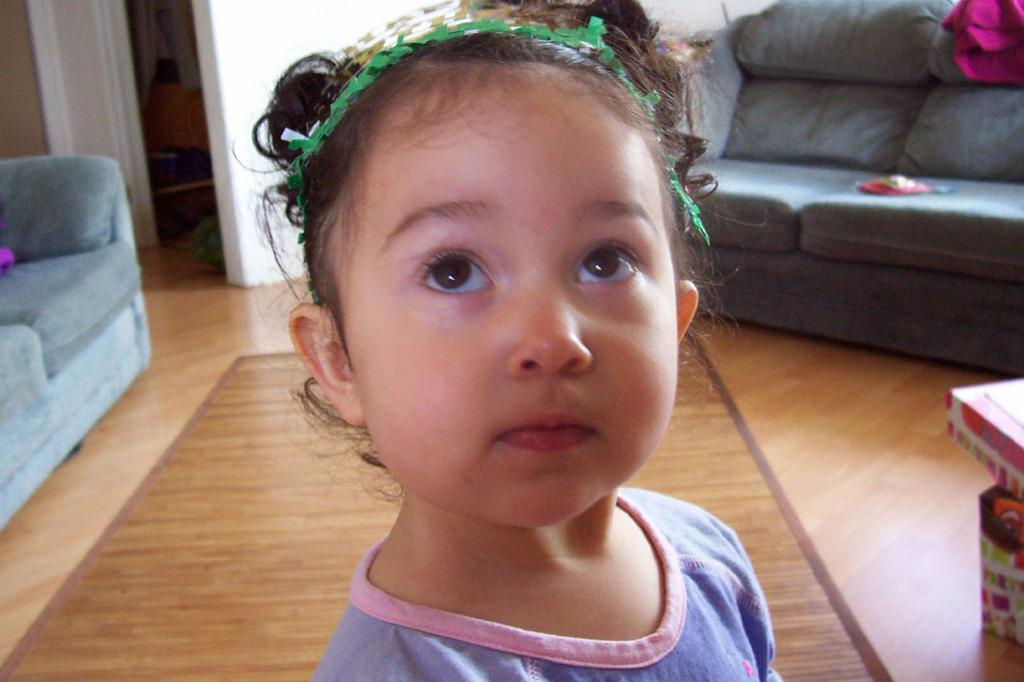Who is the main subject in the image? There is a girl in the image. What is the girl doing in the image? The girl is standing on the floor. What can be seen in the background of the image? There are sofas and a wall in the background of the image. What type of jelly is being used to hold up the tent in the image? There is no tent or jelly present in the image. 